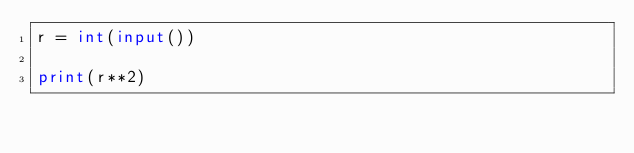<code> <loc_0><loc_0><loc_500><loc_500><_Python_>r = int(input())

print(r**2)</code> 